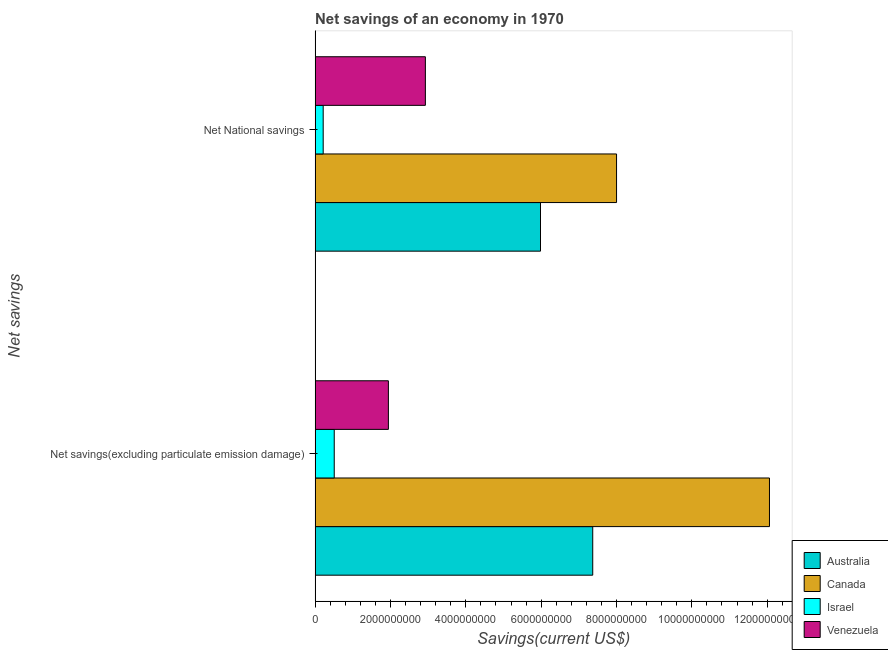How many bars are there on the 1st tick from the bottom?
Provide a short and direct response. 4. What is the label of the 2nd group of bars from the top?
Ensure brevity in your answer.  Net savings(excluding particulate emission damage). What is the net savings(excluding particulate emission damage) in Israel?
Offer a very short reply. 5.08e+08. Across all countries, what is the maximum net savings(excluding particulate emission damage)?
Your answer should be very brief. 1.21e+1. Across all countries, what is the minimum net savings(excluding particulate emission damage)?
Your answer should be very brief. 5.08e+08. In which country was the net national savings maximum?
Provide a succinct answer. Canada. In which country was the net savings(excluding particulate emission damage) minimum?
Offer a very short reply. Israel. What is the total net savings(excluding particulate emission damage) in the graph?
Offer a very short reply. 2.19e+1. What is the difference between the net national savings in Australia and that in Canada?
Offer a very short reply. -2.02e+09. What is the difference between the net savings(excluding particulate emission damage) in Canada and the net national savings in Venezuela?
Offer a very short reply. 9.13e+09. What is the average net savings(excluding particulate emission damage) per country?
Offer a terse response. 5.47e+09. What is the difference between the net savings(excluding particulate emission damage) and net national savings in Israel?
Your answer should be very brief. 2.93e+08. In how many countries, is the net savings(excluding particulate emission damage) greater than 11600000000 US$?
Ensure brevity in your answer.  1. What is the ratio of the net national savings in Australia to that in Israel?
Give a very brief answer. 27.88. Is the net national savings in Israel less than that in Australia?
Provide a short and direct response. Yes. What does the 1st bar from the top in Net savings(excluding particulate emission damage) represents?
Provide a short and direct response. Venezuela. What does the 4th bar from the bottom in Net National savings represents?
Ensure brevity in your answer.  Venezuela. What is the difference between two consecutive major ticks on the X-axis?
Give a very brief answer. 2.00e+09. Does the graph contain grids?
Your response must be concise. No. What is the title of the graph?
Make the answer very short. Net savings of an economy in 1970. Does "Kazakhstan" appear as one of the legend labels in the graph?
Your answer should be very brief. No. What is the label or title of the X-axis?
Provide a succinct answer. Savings(current US$). What is the label or title of the Y-axis?
Your answer should be compact. Net savings. What is the Savings(current US$) of Australia in Net savings(excluding particulate emission damage)?
Give a very brief answer. 7.37e+09. What is the Savings(current US$) of Canada in Net savings(excluding particulate emission damage)?
Provide a succinct answer. 1.21e+1. What is the Savings(current US$) in Israel in Net savings(excluding particulate emission damage)?
Offer a terse response. 5.08e+08. What is the Savings(current US$) of Venezuela in Net savings(excluding particulate emission damage)?
Provide a short and direct response. 1.95e+09. What is the Savings(current US$) in Australia in Net National savings?
Make the answer very short. 5.98e+09. What is the Savings(current US$) of Canada in Net National savings?
Provide a short and direct response. 8.00e+09. What is the Savings(current US$) of Israel in Net National savings?
Ensure brevity in your answer.  2.15e+08. What is the Savings(current US$) in Venezuela in Net National savings?
Your answer should be very brief. 2.93e+09. Across all Net savings, what is the maximum Savings(current US$) in Australia?
Offer a terse response. 7.37e+09. Across all Net savings, what is the maximum Savings(current US$) in Canada?
Provide a short and direct response. 1.21e+1. Across all Net savings, what is the maximum Savings(current US$) of Israel?
Offer a very short reply. 5.08e+08. Across all Net savings, what is the maximum Savings(current US$) of Venezuela?
Provide a short and direct response. 2.93e+09. Across all Net savings, what is the minimum Savings(current US$) of Australia?
Your answer should be compact. 5.98e+09. Across all Net savings, what is the minimum Savings(current US$) in Canada?
Your response must be concise. 8.00e+09. Across all Net savings, what is the minimum Savings(current US$) of Israel?
Offer a terse response. 2.15e+08. Across all Net savings, what is the minimum Savings(current US$) in Venezuela?
Your answer should be compact. 1.95e+09. What is the total Savings(current US$) of Australia in the graph?
Your response must be concise. 1.34e+1. What is the total Savings(current US$) in Canada in the graph?
Your answer should be very brief. 2.01e+1. What is the total Savings(current US$) in Israel in the graph?
Provide a short and direct response. 7.23e+08. What is the total Savings(current US$) of Venezuela in the graph?
Keep it short and to the point. 4.87e+09. What is the difference between the Savings(current US$) in Australia in Net savings(excluding particulate emission damage) and that in Net National savings?
Offer a terse response. 1.39e+09. What is the difference between the Savings(current US$) of Canada in Net savings(excluding particulate emission damage) and that in Net National savings?
Your answer should be compact. 4.06e+09. What is the difference between the Savings(current US$) in Israel in Net savings(excluding particulate emission damage) and that in Net National savings?
Offer a terse response. 2.93e+08. What is the difference between the Savings(current US$) in Venezuela in Net savings(excluding particulate emission damage) and that in Net National savings?
Provide a short and direct response. -9.82e+08. What is the difference between the Savings(current US$) of Australia in Net savings(excluding particulate emission damage) and the Savings(current US$) of Canada in Net National savings?
Offer a terse response. -6.32e+08. What is the difference between the Savings(current US$) in Australia in Net savings(excluding particulate emission damage) and the Savings(current US$) in Israel in Net National savings?
Offer a terse response. 7.16e+09. What is the difference between the Savings(current US$) of Australia in Net savings(excluding particulate emission damage) and the Savings(current US$) of Venezuela in Net National savings?
Offer a very short reply. 4.44e+09. What is the difference between the Savings(current US$) of Canada in Net savings(excluding particulate emission damage) and the Savings(current US$) of Israel in Net National savings?
Give a very brief answer. 1.18e+1. What is the difference between the Savings(current US$) in Canada in Net savings(excluding particulate emission damage) and the Savings(current US$) in Venezuela in Net National savings?
Provide a succinct answer. 9.13e+09. What is the difference between the Savings(current US$) of Israel in Net savings(excluding particulate emission damage) and the Savings(current US$) of Venezuela in Net National savings?
Provide a succinct answer. -2.42e+09. What is the average Savings(current US$) of Australia per Net savings?
Provide a short and direct response. 6.68e+09. What is the average Savings(current US$) in Canada per Net savings?
Keep it short and to the point. 1.00e+1. What is the average Savings(current US$) of Israel per Net savings?
Offer a very short reply. 3.61e+08. What is the average Savings(current US$) of Venezuela per Net savings?
Keep it short and to the point. 2.44e+09. What is the difference between the Savings(current US$) in Australia and Savings(current US$) in Canada in Net savings(excluding particulate emission damage)?
Give a very brief answer. -4.69e+09. What is the difference between the Savings(current US$) of Australia and Savings(current US$) of Israel in Net savings(excluding particulate emission damage)?
Make the answer very short. 6.86e+09. What is the difference between the Savings(current US$) of Australia and Savings(current US$) of Venezuela in Net savings(excluding particulate emission damage)?
Provide a succinct answer. 5.42e+09. What is the difference between the Savings(current US$) in Canada and Savings(current US$) in Israel in Net savings(excluding particulate emission damage)?
Make the answer very short. 1.16e+1. What is the difference between the Savings(current US$) of Canada and Savings(current US$) of Venezuela in Net savings(excluding particulate emission damage)?
Keep it short and to the point. 1.01e+1. What is the difference between the Savings(current US$) in Israel and Savings(current US$) in Venezuela in Net savings(excluding particulate emission damage)?
Make the answer very short. -1.44e+09. What is the difference between the Savings(current US$) in Australia and Savings(current US$) in Canada in Net National savings?
Offer a very short reply. -2.02e+09. What is the difference between the Savings(current US$) of Australia and Savings(current US$) of Israel in Net National savings?
Your response must be concise. 5.77e+09. What is the difference between the Savings(current US$) in Australia and Savings(current US$) in Venezuela in Net National savings?
Your answer should be compact. 3.06e+09. What is the difference between the Savings(current US$) of Canada and Savings(current US$) of Israel in Net National savings?
Your answer should be very brief. 7.79e+09. What is the difference between the Savings(current US$) in Canada and Savings(current US$) in Venezuela in Net National savings?
Give a very brief answer. 5.07e+09. What is the difference between the Savings(current US$) in Israel and Savings(current US$) in Venezuela in Net National savings?
Your response must be concise. -2.71e+09. What is the ratio of the Savings(current US$) in Australia in Net savings(excluding particulate emission damage) to that in Net National savings?
Offer a terse response. 1.23. What is the ratio of the Savings(current US$) in Canada in Net savings(excluding particulate emission damage) to that in Net National savings?
Provide a short and direct response. 1.51. What is the ratio of the Savings(current US$) of Israel in Net savings(excluding particulate emission damage) to that in Net National savings?
Offer a very short reply. 2.37. What is the ratio of the Savings(current US$) in Venezuela in Net savings(excluding particulate emission damage) to that in Net National savings?
Your answer should be compact. 0.66. What is the difference between the highest and the second highest Savings(current US$) of Australia?
Give a very brief answer. 1.39e+09. What is the difference between the highest and the second highest Savings(current US$) in Canada?
Offer a very short reply. 4.06e+09. What is the difference between the highest and the second highest Savings(current US$) of Israel?
Your answer should be compact. 2.93e+08. What is the difference between the highest and the second highest Savings(current US$) of Venezuela?
Your answer should be very brief. 9.82e+08. What is the difference between the highest and the lowest Savings(current US$) in Australia?
Make the answer very short. 1.39e+09. What is the difference between the highest and the lowest Savings(current US$) in Canada?
Your answer should be compact. 4.06e+09. What is the difference between the highest and the lowest Savings(current US$) of Israel?
Offer a very short reply. 2.93e+08. What is the difference between the highest and the lowest Savings(current US$) in Venezuela?
Your answer should be compact. 9.82e+08. 